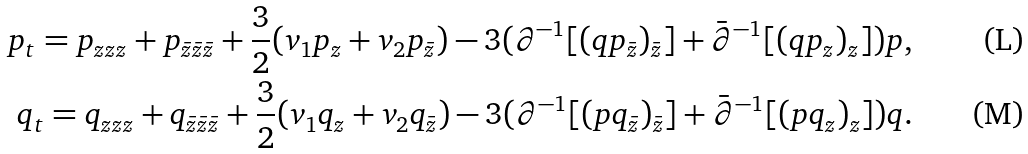<formula> <loc_0><loc_0><loc_500><loc_500>p _ { t } = p _ { z z z } + p _ { \bar { z } \bar { z } \bar { z } } + \frac { 3 } { 2 } ( v _ { 1 } p _ { z } + v _ { 2 } p _ { \bar { z } } ) - 3 ( \partial ^ { - 1 } [ ( q p _ { \bar { z } } ) _ { \bar { z } } ] + \bar { \partial } ^ { - 1 } [ ( q p _ { z } ) _ { z } ] ) p , \\ q _ { t } = q _ { z z z } + q _ { \bar { z } \bar { z } \bar { z } } + \frac { 3 } { 2 } ( v _ { 1 } q _ { z } + v _ { 2 } q _ { \bar { z } } ) - 3 ( \partial ^ { - 1 } [ ( p q _ { \bar { z } } ) _ { \bar { z } } ] + \bar { \partial } ^ { - 1 } [ ( p q _ { z } ) _ { z } ] ) q .</formula> 